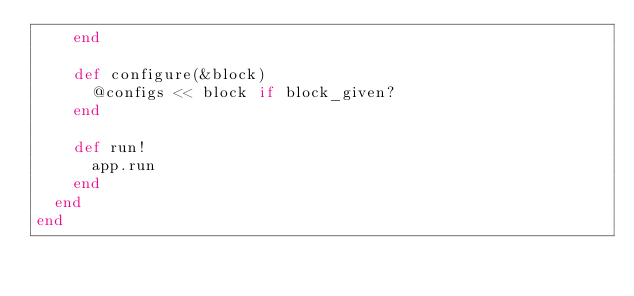<code> <loc_0><loc_0><loc_500><loc_500><_Ruby_>    end

    def configure(&block)
      @configs << block if block_given?
    end

    def run!
      app.run
    end
  end
end
</code> 